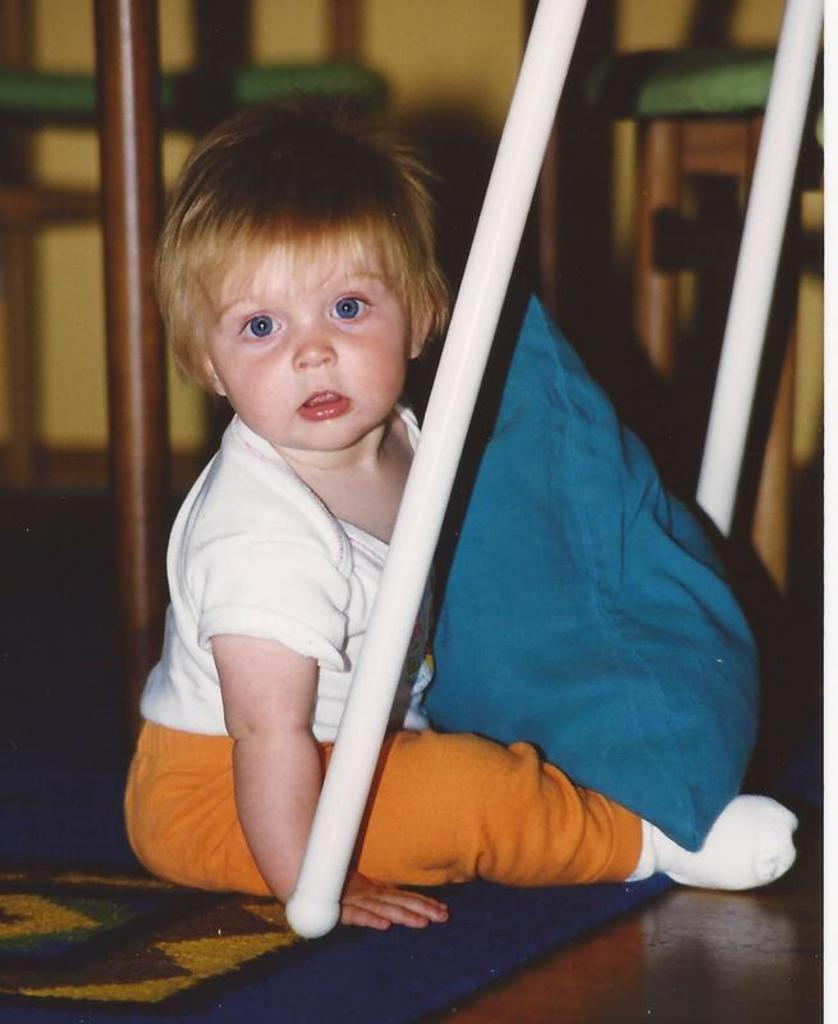What is the kid doing in the image? The kid is sitting on the carpet in the image. What type of furniture is present in the image? There is a pillow visible in the image. What objects are made of wood in the image? There are sticks visible in the image. What can be seen in the background of the image? There are stools and a wall in the background of the image. What type of wire is being used to control the cars in the image? There are no cars or wires present in the image. What is the cause of death for the person in the image? There is no person or indication of death in the image. 